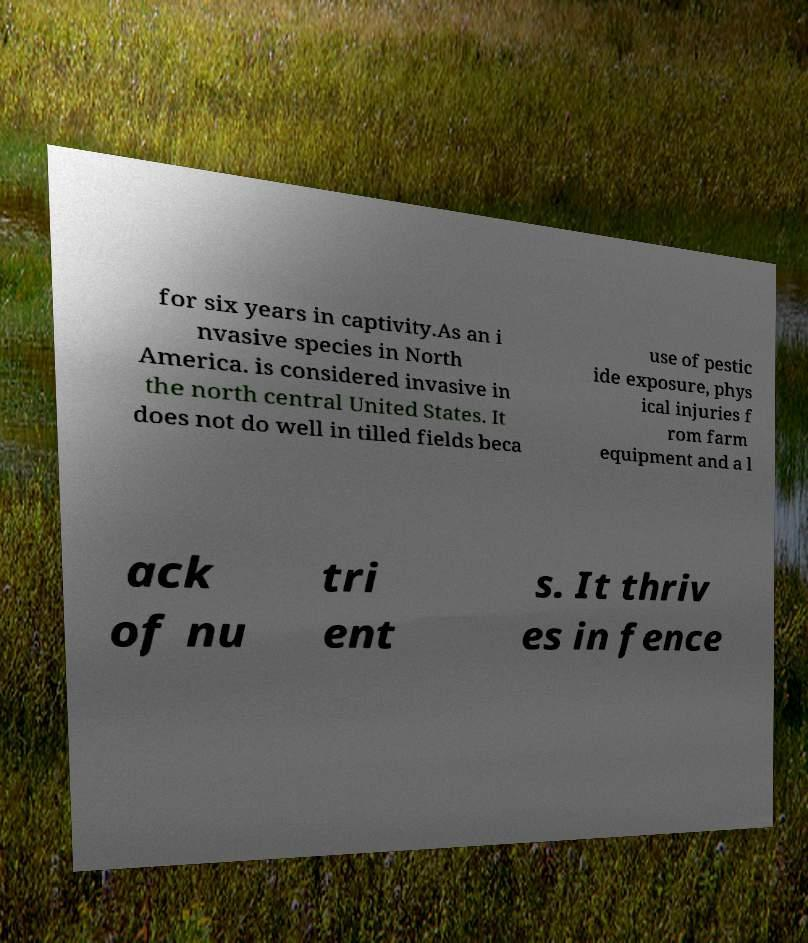Can you accurately transcribe the text from the provided image for me? for six years in captivity.As an i nvasive species in North America. is considered invasive in the north central United States. It does not do well in tilled fields beca use of pestic ide exposure, phys ical injuries f rom farm equipment and a l ack of nu tri ent s. It thriv es in fence 